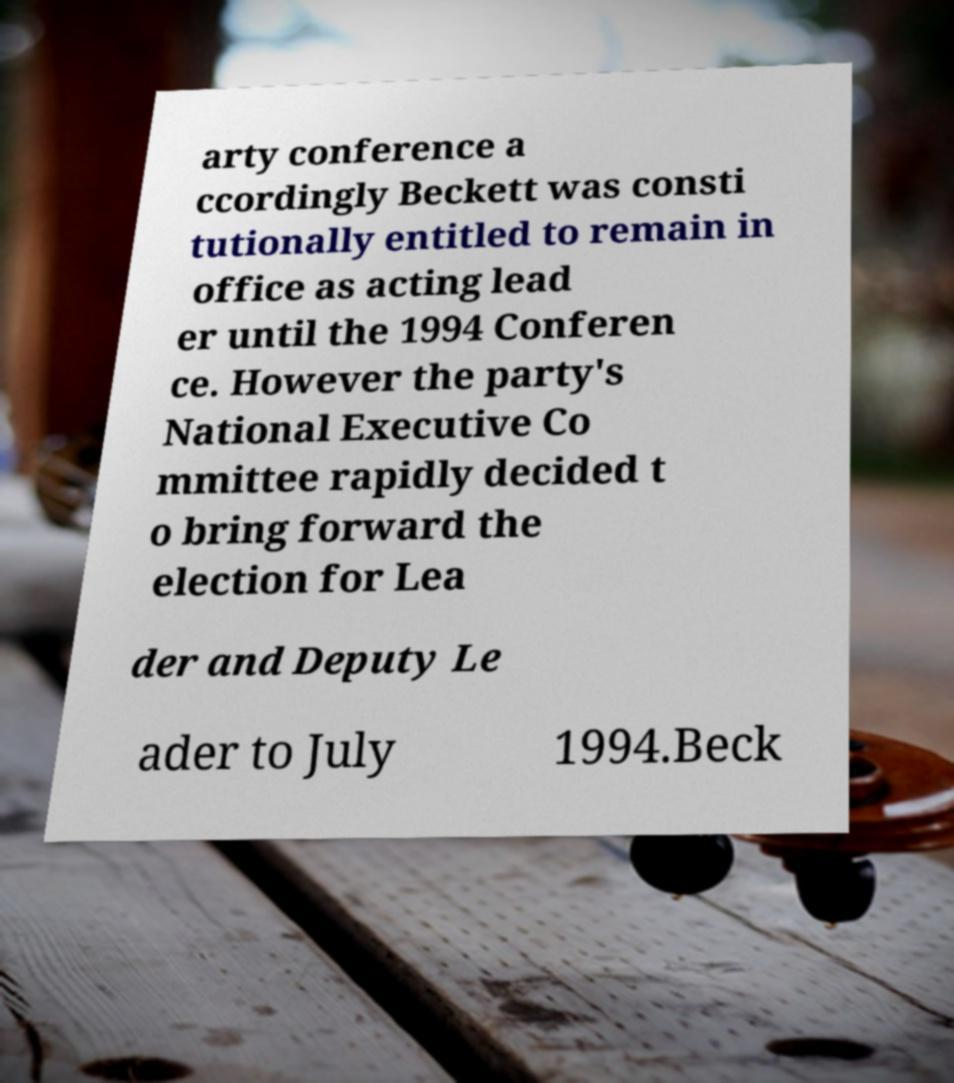Please read and relay the text visible in this image. What does it say? arty conference a ccordingly Beckett was consti tutionally entitled to remain in office as acting lead er until the 1994 Conferen ce. However the party's National Executive Co mmittee rapidly decided t o bring forward the election for Lea der and Deputy Le ader to July 1994.Beck 